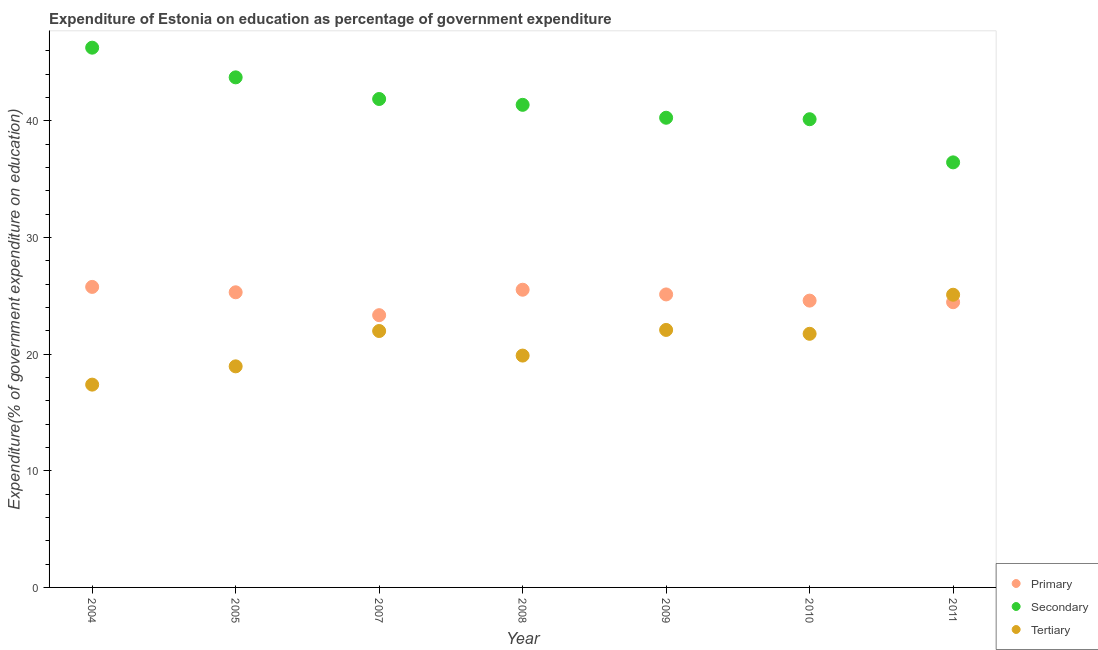Is the number of dotlines equal to the number of legend labels?
Your answer should be compact. Yes. What is the expenditure on secondary education in 2008?
Your answer should be very brief. 41.36. Across all years, what is the maximum expenditure on tertiary education?
Your response must be concise. 25.09. Across all years, what is the minimum expenditure on primary education?
Your response must be concise. 23.33. What is the total expenditure on secondary education in the graph?
Offer a very short reply. 290.02. What is the difference between the expenditure on secondary education in 2008 and that in 2011?
Offer a terse response. 4.93. What is the difference between the expenditure on tertiary education in 2011 and the expenditure on primary education in 2007?
Provide a succinct answer. 1.75. What is the average expenditure on secondary education per year?
Provide a succinct answer. 41.43. In the year 2005, what is the difference between the expenditure on secondary education and expenditure on tertiary education?
Your response must be concise. 24.77. What is the ratio of the expenditure on secondary education in 2005 to that in 2008?
Keep it short and to the point. 1.06. What is the difference between the highest and the second highest expenditure on secondary education?
Provide a succinct answer. 2.54. What is the difference between the highest and the lowest expenditure on tertiary education?
Your answer should be very brief. 7.7. In how many years, is the expenditure on primary education greater than the average expenditure on primary education taken over all years?
Make the answer very short. 4. Is it the case that in every year, the sum of the expenditure on primary education and expenditure on secondary education is greater than the expenditure on tertiary education?
Provide a short and direct response. Yes. Does the expenditure on secondary education monotonically increase over the years?
Offer a very short reply. No. Is the expenditure on tertiary education strictly greater than the expenditure on secondary education over the years?
Make the answer very short. No. How many years are there in the graph?
Offer a terse response. 7. What is the difference between two consecutive major ticks on the Y-axis?
Your answer should be compact. 10. How many legend labels are there?
Your answer should be very brief. 3. What is the title of the graph?
Your answer should be compact. Expenditure of Estonia on education as percentage of government expenditure. Does "Grants" appear as one of the legend labels in the graph?
Give a very brief answer. No. What is the label or title of the X-axis?
Make the answer very short. Year. What is the label or title of the Y-axis?
Provide a short and direct response. Expenditure(% of government expenditure on education). What is the Expenditure(% of government expenditure on education) in Primary in 2004?
Ensure brevity in your answer.  25.76. What is the Expenditure(% of government expenditure on education) in Secondary in 2004?
Keep it short and to the point. 46.26. What is the Expenditure(% of government expenditure on education) in Tertiary in 2004?
Provide a succinct answer. 17.38. What is the Expenditure(% of government expenditure on education) of Primary in 2005?
Offer a very short reply. 25.3. What is the Expenditure(% of government expenditure on education) of Secondary in 2005?
Offer a very short reply. 43.72. What is the Expenditure(% of government expenditure on education) of Tertiary in 2005?
Your answer should be very brief. 18.95. What is the Expenditure(% of government expenditure on education) of Primary in 2007?
Provide a short and direct response. 23.33. What is the Expenditure(% of government expenditure on education) of Secondary in 2007?
Provide a short and direct response. 41.86. What is the Expenditure(% of government expenditure on education) of Tertiary in 2007?
Ensure brevity in your answer.  21.98. What is the Expenditure(% of government expenditure on education) in Primary in 2008?
Make the answer very short. 25.52. What is the Expenditure(% of government expenditure on education) in Secondary in 2008?
Your answer should be compact. 41.36. What is the Expenditure(% of government expenditure on education) of Tertiary in 2008?
Provide a succinct answer. 19.87. What is the Expenditure(% of government expenditure on education) in Primary in 2009?
Give a very brief answer. 25.11. What is the Expenditure(% of government expenditure on education) in Secondary in 2009?
Offer a very short reply. 40.25. What is the Expenditure(% of government expenditure on education) in Tertiary in 2009?
Give a very brief answer. 22.07. What is the Expenditure(% of government expenditure on education) in Primary in 2010?
Make the answer very short. 24.58. What is the Expenditure(% of government expenditure on education) of Secondary in 2010?
Offer a terse response. 40.13. What is the Expenditure(% of government expenditure on education) in Tertiary in 2010?
Provide a succinct answer. 21.74. What is the Expenditure(% of government expenditure on education) in Primary in 2011?
Your answer should be very brief. 24.45. What is the Expenditure(% of government expenditure on education) of Secondary in 2011?
Keep it short and to the point. 36.43. What is the Expenditure(% of government expenditure on education) in Tertiary in 2011?
Ensure brevity in your answer.  25.09. Across all years, what is the maximum Expenditure(% of government expenditure on education) of Primary?
Make the answer very short. 25.76. Across all years, what is the maximum Expenditure(% of government expenditure on education) in Secondary?
Your answer should be compact. 46.26. Across all years, what is the maximum Expenditure(% of government expenditure on education) in Tertiary?
Ensure brevity in your answer.  25.09. Across all years, what is the minimum Expenditure(% of government expenditure on education) in Primary?
Provide a succinct answer. 23.33. Across all years, what is the minimum Expenditure(% of government expenditure on education) in Secondary?
Keep it short and to the point. 36.43. Across all years, what is the minimum Expenditure(% of government expenditure on education) in Tertiary?
Provide a succinct answer. 17.38. What is the total Expenditure(% of government expenditure on education) in Primary in the graph?
Give a very brief answer. 174.04. What is the total Expenditure(% of government expenditure on education) in Secondary in the graph?
Give a very brief answer. 290.02. What is the total Expenditure(% of government expenditure on education) in Tertiary in the graph?
Keep it short and to the point. 147.07. What is the difference between the Expenditure(% of government expenditure on education) in Primary in 2004 and that in 2005?
Offer a terse response. 0.46. What is the difference between the Expenditure(% of government expenditure on education) in Secondary in 2004 and that in 2005?
Provide a short and direct response. 2.54. What is the difference between the Expenditure(% of government expenditure on education) in Tertiary in 2004 and that in 2005?
Make the answer very short. -1.57. What is the difference between the Expenditure(% of government expenditure on education) of Primary in 2004 and that in 2007?
Offer a terse response. 2.42. What is the difference between the Expenditure(% of government expenditure on education) in Secondary in 2004 and that in 2007?
Provide a short and direct response. 4.4. What is the difference between the Expenditure(% of government expenditure on education) of Tertiary in 2004 and that in 2007?
Offer a very short reply. -4.6. What is the difference between the Expenditure(% of government expenditure on education) of Primary in 2004 and that in 2008?
Keep it short and to the point. 0.24. What is the difference between the Expenditure(% of government expenditure on education) in Secondary in 2004 and that in 2008?
Your answer should be compact. 4.9. What is the difference between the Expenditure(% of government expenditure on education) of Tertiary in 2004 and that in 2008?
Make the answer very short. -2.49. What is the difference between the Expenditure(% of government expenditure on education) in Primary in 2004 and that in 2009?
Ensure brevity in your answer.  0.65. What is the difference between the Expenditure(% of government expenditure on education) in Secondary in 2004 and that in 2009?
Offer a very short reply. 6.01. What is the difference between the Expenditure(% of government expenditure on education) of Tertiary in 2004 and that in 2009?
Your answer should be compact. -4.69. What is the difference between the Expenditure(% of government expenditure on education) in Primary in 2004 and that in 2010?
Ensure brevity in your answer.  1.18. What is the difference between the Expenditure(% of government expenditure on education) in Secondary in 2004 and that in 2010?
Your response must be concise. 6.13. What is the difference between the Expenditure(% of government expenditure on education) in Tertiary in 2004 and that in 2010?
Ensure brevity in your answer.  -4.36. What is the difference between the Expenditure(% of government expenditure on education) in Primary in 2004 and that in 2011?
Keep it short and to the point. 1.31. What is the difference between the Expenditure(% of government expenditure on education) of Secondary in 2004 and that in 2011?
Your answer should be compact. 9.83. What is the difference between the Expenditure(% of government expenditure on education) in Tertiary in 2004 and that in 2011?
Ensure brevity in your answer.  -7.7. What is the difference between the Expenditure(% of government expenditure on education) in Primary in 2005 and that in 2007?
Provide a succinct answer. 1.96. What is the difference between the Expenditure(% of government expenditure on education) of Secondary in 2005 and that in 2007?
Make the answer very short. 1.85. What is the difference between the Expenditure(% of government expenditure on education) in Tertiary in 2005 and that in 2007?
Provide a short and direct response. -3.03. What is the difference between the Expenditure(% of government expenditure on education) in Primary in 2005 and that in 2008?
Make the answer very short. -0.22. What is the difference between the Expenditure(% of government expenditure on education) in Secondary in 2005 and that in 2008?
Provide a short and direct response. 2.36. What is the difference between the Expenditure(% of government expenditure on education) of Tertiary in 2005 and that in 2008?
Ensure brevity in your answer.  -0.92. What is the difference between the Expenditure(% of government expenditure on education) of Primary in 2005 and that in 2009?
Offer a very short reply. 0.18. What is the difference between the Expenditure(% of government expenditure on education) of Secondary in 2005 and that in 2009?
Provide a succinct answer. 3.46. What is the difference between the Expenditure(% of government expenditure on education) in Tertiary in 2005 and that in 2009?
Make the answer very short. -3.12. What is the difference between the Expenditure(% of government expenditure on education) of Primary in 2005 and that in 2010?
Your answer should be compact. 0.71. What is the difference between the Expenditure(% of government expenditure on education) of Secondary in 2005 and that in 2010?
Ensure brevity in your answer.  3.59. What is the difference between the Expenditure(% of government expenditure on education) of Tertiary in 2005 and that in 2010?
Your answer should be compact. -2.79. What is the difference between the Expenditure(% of government expenditure on education) in Primary in 2005 and that in 2011?
Give a very brief answer. 0.85. What is the difference between the Expenditure(% of government expenditure on education) in Secondary in 2005 and that in 2011?
Offer a terse response. 7.29. What is the difference between the Expenditure(% of government expenditure on education) in Tertiary in 2005 and that in 2011?
Make the answer very short. -6.14. What is the difference between the Expenditure(% of government expenditure on education) in Primary in 2007 and that in 2008?
Ensure brevity in your answer.  -2.18. What is the difference between the Expenditure(% of government expenditure on education) of Secondary in 2007 and that in 2008?
Offer a terse response. 0.5. What is the difference between the Expenditure(% of government expenditure on education) in Tertiary in 2007 and that in 2008?
Provide a short and direct response. 2.11. What is the difference between the Expenditure(% of government expenditure on education) in Primary in 2007 and that in 2009?
Your answer should be very brief. -1.78. What is the difference between the Expenditure(% of government expenditure on education) in Secondary in 2007 and that in 2009?
Your answer should be very brief. 1.61. What is the difference between the Expenditure(% of government expenditure on education) of Tertiary in 2007 and that in 2009?
Give a very brief answer. -0.09. What is the difference between the Expenditure(% of government expenditure on education) in Primary in 2007 and that in 2010?
Your response must be concise. -1.25. What is the difference between the Expenditure(% of government expenditure on education) of Secondary in 2007 and that in 2010?
Your answer should be compact. 1.73. What is the difference between the Expenditure(% of government expenditure on education) in Tertiary in 2007 and that in 2010?
Your answer should be very brief. 0.24. What is the difference between the Expenditure(% of government expenditure on education) of Primary in 2007 and that in 2011?
Offer a terse response. -1.11. What is the difference between the Expenditure(% of government expenditure on education) in Secondary in 2007 and that in 2011?
Give a very brief answer. 5.43. What is the difference between the Expenditure(% of government expenditure on education) in Tertiary in 2007 and that in 2011?
Provide a succinct answer. -3.11. What is the difference between the Expenditure(% of government expenditure on education) of Primary in 2008 and that in 2009?
Your answer should be compact. 0.4. What is the difference between the Expenditure(% of government expenditure on education) in Secondary in 2008 and that in 2009?
Offer a terse response. 1.11. What is the difference between the Expenditure(% of government expenditure on education) of Tertiary in 2008 and that in 2009?
Your answer should be compact. -2.2. What is the difference between the Expenditure(% of government expenditure on education) of Primary in 2008 and that in 2010?
Make the answer very short. 0.93. What is the difference between the Expenditure(% of government expenditure on education) of Secondary in 2008 and that in 2010?
Offer a terse response. 1.23. What is the difference between the Expenditure(% of government expenditure on education) of Tertiary in 2008 and that in 2010?
Provide a short and direct response. -1.87. What is the difference between the Expenditure(% of government expenditure on education) of Primary in 2008 and that in 2011?
Your answer should be compact. 1.07. What is the difference between the Expenditure(% of government expenditure on education) of Secondary in 2008 and that in 2011?
Provide a short and direct response. 4.93. What is the difference between the Expenditure(% of government expenditure on education) of Tertiary in 2008 and that in 2011?
Make the answer very short. -5.21. What is the difference between the Expenditure(% of government expenditure on education) in Primary in 2009 and that in 2010?
Offer a terse response. 0.53. What is the difference between the Expenditure(% of government expenditure on education) in Secondary in 2009 and that in 2010?
Provide a short and direct response. 0.13. What is the difference between the Expenditure(% of government expenditure on education) in Tertiary in 2009 and that in 2010?
Make the answer very short. 0.33. What is the difference between the Expenditure(% of government expenditure on education) in Primary in 2009 and that in 2011?
Provide a short and direct response. 0.67. What is the difference between the Expenditure(% of government expenditure on education) of Secondary in 2009 and that in 2011?
Provide a short and direct response. 3.82. What is the difference between the Expenditure(% of government expenditure on education) of Tertiary in 2009 and that in 2011?
Provide a short and direct response. -3.02. What is the difference between the Expenditure(% of government expenditure on education) of Primary in 2010 and that in 2011?
Your response must be concise. 0.14. What is the difference between the Expenditure(% of government expenditure on education) of Secondary in 2010 and that in 2011?
Your answer should be very brief. 3.7. What is the difference between the Expenditure(% of government expenditure on education) in Tertiary in 2010 and that in 2011?
Give a very brief answer. -3.35. What is the difference between the Expenditure(% of government expenditure on education) in Primary in 2004 and the Expenditure(% of government expenditure on education) in Secondary in 2005?
Offer a very short reply. -17.96. What is the difference between the Expenditure(% of government expenditure on education) in Primary in 2004 and the Expenditure(% of government expenditure on education) in Tertiary in 2005?
Keep it short and to the point. 6.81. What is the difference between the Expenditure(% of government expenditure on education) of Secondary in 2004 and the Expenditure(% of government expenditure on education) of Tertiary in 2005?
Provide a short and direct response. 27.31. What is the difference between the Expenditure(% of government expenditure on education) of Primary in 2004 and the Expenditure(% of government expenditure on education) of Secondary in 2007?
Provide a succinct answer. -16.1. What is the difference between the Expenditure(% of government expenditure on education) in Primary in 2004 and the Expenditure(% of government expenditure on education) in Tertiary in 2007?
Your response must be concise. 3.78. What is the difference between the Expenditure(% of government expenditure on education) in Secondary in 2004 and the Expenditure(% of government expenditure on education) in Tertiary in 2007?
Offer a terse response. 24.28. What is the difference between the Expenditure(% of government expenditure on education) of Primary in 2004 and the Expenditure(% of government expenditure on education) of Secondary in 2008?
Offer a terse response. -15.6. What is the difference between the Expenditure(% of government expenditure on education) in Primary in 2004 and the Expenditure(% of government expenditure on education) in Tertiary in 2008?
Keep it short and to the point. 5.89. What is the difference between the Expenditure(% of government expenditure on education) in Secondary in 2004 and the Expenditure(% of government expenditure on education) in Tertiary in 2008?
Your answer should be compact. 26.39. What is the difference between the Expenditure(% of government expenditure on education) in Primary in 2004 and the Expenditure(% of government expenditure on education) in Secondary in 2009?
Your answer should be compact. -14.5. What is the difference between the Expenditure(% of government expenditure on education) of Primary in 2004 and the Expenditure(% of government expenditure on education) of Tertiary in 2009?
Offer a very short reply. 3.69. What is the difference between the Expenditure(% of government expenditure on education) in Secondary in 2004 and the Expenditure(% of government expenditure on education) in Tertiary in 2009?
Offer a terse response. 24.19. What is the difference between the Expenditure(% of government expenditure on education) in Primary in 2004 and the Expenditure(% of government expenditure on education) in Secondary in 2010?
Your answer should be very brief. -14.37. What is the difference between the Expenditure(% of government expenditure on education) of Primary in 2004 and the Expenditure(% of government expenditure on education) of Tertiary in 2010?
Give a very brief answer. 4.02. What is the difference between the Expenditure(% of government expenditure on education) in Secondary in 2004 and the Expenditure(% of government expenditure on education) in Tertiary in 2010?
Give a very brief answer. 24.52. What is the difference between the Expenditure(% of government expenditure on education) of Primary in 2004 and the Expenditure(% of government expenditure on education) of Secondary in 2011?
Offer a very short reply. -10.67. What is the difference between the Expenditure(% of government expenditure on education) in Primary in 2004 and the Expenditure(% of government expenditure on education) in Tertiary in 2011?
Your response must be concise. 0.67. What is the difference between the Expenditure(% of government expenditure on education) in Secondary in 2004 and the Expenditure(% of government expenditure on education) in Tertiary in 2011?
Ensure brevity in your answer.  21.18. What is the difference between the Expenditure(% of government expenditure on education) in Primary in 2005 and the Expenditure(% of government expenditure on education) in Secondary in 2007?
Provide a short and direct response. -16.57. What is the difference between the Expenditure(% of government expenditure on education) in Primary in 2005 and the Expenditure(% of government expenditure on education) in Tertiary in 2007?
Offer a terse response. 3.32. What is the difference between the Expenditure(% of government expenditure on education) in Secondary in 2005 and the Expenditure(% of government expenditure on education) in Tertiary in 2007?
Offer a terse response. 21.74. What is the difference between the Expenditure(% of government expenditure on education) of Primary in 2005 and the Expenditure(% of government expenditure on education) of Secondary in 2008?
Make the answer very short. -16.07. What is the difference between the Expenditure(% of government expenditure on education) of Primary in 2005 and the Expenditure(% of government expenditure on education) of Tertiary in 2008?
Provide a succinct answer. 5.42. What is the difference between the Expenditure(% of government expenditure on education) of Secondary in 2005 and the Expenditure(% of government expenditure on education) of Tertiary in 2008?
Your response must be concise. 23.85. What is the difference between the Expenditure(% of government expenditure on education) in Primary in 2005 and the Expenditure(% of government expenditure on education) in Secondary in 2009?
Provide a succinct answer. -14.96. What is the difference between the Expenditure(% of government expenditure on education) of Primary in 2005 and the Expenditure(% of government expenditure on education) of Tertiary in 2009?
Your answer should be compact. 3.23. What is the difference between the Expenditure(% of government expenditure on education) of Secondary in 2005 and the Expenditure(% of government expenditure on education) of Tertiary in 2009?
Provide a succinct answer. 21.65. What is the difference between the Expenditure(% of government expenditure on education) of Primary in 2005 and the Expenditure(% of government expenditure on education) of Secondary in 2010?
Keep it short and to the point. -14.83. What is the difference between the Expenditure(% of government expenditure on education) in Primary in 2005 and the Expenditure(% of government expenditure on education) in Tertiary in 2010?
Provide a short and direct response. 3.56. What is the difference between the Expenditure(% of government expenditure on education) of Secondary in 2005 and the Expenditure(% of government expenditure on education) of Tertiary in 2010?
Keep it short and to the point. 21.98. What is the difference between the Expenditure(% of government expenditure on education) of Primary in 2005 and the Expenditure(% of government expenditure on education) of Secondary in 2011?
Your answer should be compact. -11.13. What is the difference between the Expenditure(% of government expenditure on education) of Primary in 2005 and the Expenditure(% of government expenditure on education) of Tertiary in 2011?
Your answer should be very brief. 0.21. What is the difference between the Expenditure(% of government expenditure on education) in Secondary in 2005 and the Expenditure(% of government expenditure on education) in Tertiary in 2011?
Give a very brief answer. 18.63. What is the difference between the Expenditure(% of government expenditure on education) in Primary in 2007 and the Expenditure(% of government expenditure on education) in Secondary in 2008?
Your response must be concise. -18.03. What is the difference between the Expenditure(% of government expenditure on education) of Primary in 2007 and the Expenditure(% of government expenditure on education) of Tertiary in 2008?
Give a very brief answer. 3.46. What is the difference between the Expenditure(% of government expenditure on education) in Secondary in 2007 and the Expenditure(% of government expenditure on education) in Tertiary in 2008?
Offer a terse response. 21.99. What is the difference between the Expenditure(% of government expenditure on education) in Primary in 2007 and the Expenditure(% of government expenditure on education) in Secondary in 2009?
Keep it short and to the point. -16.92. What is the difference between the Expenditure(% of government expenditure on education) in Primary in 2007 and the Expenditure(% of government expenditure on education) in Tertiary in 2009?
Give a very brief answer. 1.26. What is the difference between the Expenditure(% of government expenditure on education) of Secondary in 2007 and the Expenditure(% of government expenditure on education) of Tertiary in 2009?
Offer a very short reply. 19.79. What is the difference between the Expenditure(% of government expenditure on education) of Primary in 2007 and the Expenditure(% of government expenditure on education) of Secondary in 2010?
Offer a very short reply. -16.79. What is the difference between the Expenditure(% of government expenditure on education) in Primary in 2007 and the Expenditure(% of government expenditure on education) in Tertiary in 2010?
Ensure brevity in your answer.  1.6. What is the difference between the Expenditure(% of government expenditure on education) in Secondary in 2007 and the Expenditure(% of government expenditure on education) in Tertiary in 2010?
Your answer should be very brief. 20.12. What is the difference between the Expenditure(% of government expenditure on education) of Primary in 2007 and the Expenditure(% of government expenditure on education) of Secondary in 2011?
Give a very brief answer. -13.1. What is the difference between the Expenditure(% of government expenditure on education) in Primary in 2007 and the Expenditure(% of government expenditure on education) in Tertiary in 2011?
Provide a succinct answer. -1.75. What is the difference between the Expenditure(% of government expenditure on education) of Secondary in 2007 and the Expenditure(% of government expenditure on education) of Tertiary in 2011?
Provide a short and direct response. 16.78. What is the difference between the Expenditure(% of government expenditure on education) in Primary in 2008 and the Expenditure(% of government expenditure on education) in Secondary in 2009?
Provide a short and direct response. -14.74. What is the difference between the Expenditure(% of government expenditure on education) of Primary in 2008 and the Expenditure(% of government expenditure on education) of Tertiary in 2009?
Give a very brief answer. 3.45. What is the difference between the Expenditure(% of government expenditure on education) of Secondary in 2008 and the Expenditure(% of government expenditure on education) of Tertiary in 2009?
Keep it short and to the point. 19.29. What is the difference between the Expenditure(% of government expenditure on education) of Primary in 2008 and the Expenditure(% of government expenditure on education) of Secondary in 2010?
Your answer should be compact. -14.61. What is the difference between the Expenditure(% of government expenditure on education) in Primary in 2008 and the Expenditure(% of government expenditure on education) in Tertiary in 2010?
Give a very brief answer. 3.78. What is the difference between the Expenditure(% of government expenditure on education) in Secondary in 2008 and the Expenditure(% of government expenditure on education) in Tertiary in 2010?
Provide a succinct answer. 19.62. What is the difference between the Expenditure(% of government expenditure on education) of Primary in 2008 and the Expenditure(% of government expenditure on education) of Secondary in 2011?
Offer a very short reply. -10.91. What is the difference between the Expenditure(% of government expenditure on education) of Primary in 2008 and the Expenditure(% of government expenditure on education) of Tertiary in 2011?
Keep it short and to the point. 0.43. What is the difference between the Expenditure(% of government expenditure on education) in Secondary in 2008 and the Expenditure(% of government expenditure on education) in Tertiary in 2011?
Offer a terse response. 16.28. What is the difference between the Expenditure(% of government expenditure on education) in Primary in 2009 and the Expenditure(% of government expenditure on education) in Secondary in 2010?
Your answer should be very brief. -15.02. What is the difference between the Expenditure(% of government expenditure on education) in Primary in 2009 and the Expenditure(% of government expenditure on education) in Tertiary in 2010?
Your response must be concise. 3.37. What is the difference between the Expenditure(% of government expenditure on education) in Secondary in 2009 and the Expenditure(% of government expenditure on education) in Tertiary in 2010?
Provide a short and direct response. 18.52. What is the difference between the Expenditure(% of government expenditure on education) of Primary in 2009 and the Expenditure(% of government expenditure on education) of Secondary in 2011?
Your answer should be very brief. -11.32. What is the difference between the Expenditure(% of government expenditure on education) of Primary in 2009 and the Expenditure(% of government expenditure on education) of Tertiary in 2011?
Your answer should be compact. 0.03. What is the difference between the Expenditure(% of government expenditure on education) in Secondary in 2009 and the Expenditure(% of government expenditure on education) in Tertiary in 2011?
Offer a terse response. 15.17. What is the difference between the Expenditure(% of government expenditure on education) in Primary in 2010 and the Expenditure(% of government expenditure on education) in Secondary in 2011?
Your response must be concise. -11.85. What is the difference between the Expenditure(% of government expenditure on education) of Primary in 2010 and the Expenditure(% of government expenditure on education) of Tertiary in 2011?
Your answer should be compact. -0.5. What is the difference between the Expenditure(% of government expenditure on education) in Secondary in 2010 and the Expenditure(% of government expenditure on education) in Tertiary in 2011?
Your answer should be compact. 15.04. What is the average Expenditure(% of government expenditure on education) of Primary per year?
Provide a succinct answer. 24.86. What is the average Expenditure(% of government expenditure on education) of Secondary per year?
Your answer should be compact. 41.43. What is the average Expenditure(% of government expenditure on education) in Tertiary per year?
Your response must be concise. 21.01. In the year 2004, what is the difference between the Expenditure(% of government expenditure on education) in Primary and Expenditure(% of government expenditure on education) in Secondary?
Offer a very short reply. -20.5. In the year 2004, what is the difference between the Expenditure(% of government expenditure on education) of Primary and Expenditure(% of government expenditure on education) of Tertiary?
Make the answer very short. 8.38. In the year 2004, what is the difference between the Expenditure(% of government expenditure on education) in Secondary and Expenditure(% of government expenditure on education) in Tertiary?
Provide a succinct answer. 28.88. In the year 2005, what is the difference between the Expenditure(% of government expenditure on education) of Primary and Expenditure(% of government expenditure on education) of Secondary?
Provide a short and direct response. -18.42. In the year 2005, what is the difference between the Expenditure(% of government expenditure on education) in Primary and Expenditure(% of government expenditure on education) in Tertiary?
Your answer should be very brief. 6.35. In the year 2005, what is the difference between the Expenditure(% of government expenditure on education) of Secondary and Expenditure(% of government expenditure on education) of Tertiary?
Your answer should be very brief. 24.77. In the year 2007, what is the difference between the Expenditure(% of government expenditure on education) of Primary and Expenditure(% of government expenditure on education) of Secondary?
Offer a very short reply. -18.53. In the year 2007, what is the difference between the Expenditure(% of government expenditure on education) in Primary and Expenditure(% of government expenditure on education) in Tertiary?
Offer a terse response. 1.36. In the year 2007, what is the difference between the Expenditure(% of government expenditure on education) of Secondary and Expenditure(% of government expenditure on education) of Tertiary?
Ensure brevity in your answer.  19.89. In the year 2008, what is the difference between the Expenditure(% of government expenditure on education) in Primary and Expenditure(% of government expenditure on education) in Secondary?
Give a very brief answer. -15.85. In the year 2008, what is the difference between the Expenditure(% of government expenditure on education) of Primary and Expenditure(% of government expenditure on education) of Tertiary?
Your answer should be compact. 5.64. In the year 2008, what is the difference between the Expenditure(% of government expenditure on education) of Secondary and Expenditure(% of government expenditure on education) of Tertiary?
Provide a succinct answer. 21.49. In the year 2009, what is the difference between the Expenditure(% of government expenditure on education) in Primary and Expenditure(% of government expenditure on education) in Secondary?
Ensure brevity in your answer.  -15.14. In the year 2009, what is the difference between the Expenditure(% of government expenditure on education) of Primary and Expenditure(% of government expenditure on education) of Tertiary?
Make the answer very short. 3.04. In the year 2009, what is the difference between the Expenditure(% of government expenditure on education) in Secondary and Expenditure(% of government expenditure on education) in Tertiary?
Give a very brief answer. 18.19. In the year 2010, what is the difference between the Expenditure(% of government expenditure on education) in Primary and Expenditure(% of government expenditure on education) in Secondary?
Offer a very short reply. -15.55. In the year 2010, what is the difference between the Expenditure(% of government expenditure on education) of Primary and Expenditure(% of government expenditure on education) of Tertiary?
Your answer should be very brief. 2.84. In the year 2010, what is the difference between the Expenditure(% of government expenditure on education) of Secondary and Expenditure(% of government expenditure on education) of Tertiary?
Give a very brief answer. 18.39. In the year 2011, what is the difference between the Expenditure(% of government expenditure on education) of Primary and Expenditure(% of government expenditure on education) of Secondary?
Offer a very short reply. -11.98. In the year 2011, what is the difference between the Expenditure(% of government expenditure on education) of Primary and Expenditure(% of government expenditure on education) of Tertiary?
Offer a terse response. -0.64. In the year 2011, what is the difference between the Expenditure(% of government expenditure on education) of Secondary and Expenditure(% of government expenditure on education) of Tertiary?
Keep it short and to the point. 11.34. What is the ratio of the Expenditure(% of government expenditure on education) in Primary in 2004 to that in 2005?
Ensure brevity in your answer.  1.02. What is the ratio of the Expenditure(% of government expenditure on education) of Secondary in 2004 to that in 2005?
Keep it short and to the point. 1.06. What is the ratio of the Expenditure(% of government expenditure on education) in Tertiary in 2004 to that in 2005?
Keep it short and to the point. 0.92. What is the ratio of the Expenditure(% of government expenditure on education) in Primary in 2004 to that in 2007?
Offer a terse response. 1.1. What is the ratio of the Expenditure(% of government expenditure on education) of Secondary in 2004 to that in 2007?
Your answer should be very brief. 1.11. What is the ratio of the Expenditure(% of government expenditure on education) in Tertiary in 2004 to that in 2007?
Give a very brief answer. 0.79. What is the ratio of the Expenditure(% of government expenditure on education) in Primary in 2004 to that in 2008?
Offer a very short reply. 1.01. What is the ratio of the Expenditure(% of government expenditure on education) in Secondary in 2004 to that in 2008?
Make the answer very short. 1.12. What is the ratio of the Expenditure(% of government expenditure on education) in Tertiary in 2004 to that in 2008?
Your response must be concise. 0.87. What is the ratio of the Expenditure(% of government expenditure on education) in Primary in 2004 to that in 2009?
Keep it short and to the point. 1.03. What is the ratio of the Expenditure(% of government expenditure on education) in Secondary in 2004 to that in 2009?
Keep it short and to the point. 1.15. What is the ratio of the Expenditure(% of government expenditure on education) of Tertiary in 2004 to that in 2009?
Provide a succinct answer. 0.79. What is the ratio of the Expenditure(% of government expenditure on education) of Primary in 2004 to that in 2010?
Provide a short and direct response. 1.05. What is the ratio of the Expenditure(% of government expenditure on education) in Secondary in 2004 to that in 2010?
Provide a succinct answer. 1.15. What is the ratio of the Expenditure(% of government expenditure on education) in Tertiary in 2004 to that in 2010?
Offer a very short reply. 0.8. What is the ratio of the Expenditure(% of government expenditure on education) of Primary in 2004 to that in 2011?
Your response must be concise. 1.05. What is the ratio of the Expenditure(% of government expenditure on education) of Secondary in 2004 to that in 2011?
Give a very brief answer. 1.27. What is the ratio of the Expenditure(% of government expenditure on education) in Tertiary in 2004 to that in 2011?
Give a very brief answer. 0.69. What is the ratio of the Expenditure(% of government expenditure on education) in Primary in 2005 to that in 2007?
Provide a short and direct response. 1.08. What is the ratio of the Expenditure(% of government expenditure on education) of Secondary in 2005 to that in 2007?
Your response must be concise. 1.04. What is the ratio of the Expenditure(% of government expenditure on education) in Tertiary in 2005 to that in 2007?
Your response must be concise. 0.86. What is the ratio of the Expenditure(% of government expenditure on education) in Primary in 2005 to that in 2008?
Make the answer very short. 0.99. What is the ratio of the Expenditure(% of government expenditure on education) in Secondary in 2005 to that in 2008?
Keep it short and to the point. 1.06. What is the ratio of the Expenditure(% of government expenditure on education) of Tertiary in 2005 to that in 2008?
Provide a short and direct response. 0.95. What is the ratio of the Expenditure(% of government expenditure on education) in Primary in 2005 to that in 2009?
Offer a very short reply. 1.01. What is the ratio of the Expenditure(% of government expenditure on education) of Secondary in 2005 to that in 2009?
Offer a terse response. 1.09. What is the ratio of the Expenditure(% of government expenditure on education) of Tertiary in 2005 to that in 2009?
Offer a very short reply. 0.86. What is the ratio of the Expenditure(% of government expenditure on education) in Secondary in 2005 to that in 2010?
Ensure brevity in your answer.  1.09. What is the ratio of the Expenditure(% of government expenditure on education) of Tertiary in 2005 to that in 2010?
Provide a short and direct response. 0.87. What is the ratio of the Expenditure(% of government expenditure on education) in Primary in 2005 to that in 2011?
Your answer should be very brief. 1.03. What is the ratio of the Expenditure(% of government expenditure on education) of Tertiary in 2005 to that in 2011?
Your response must be concise. 0.76. What is the ratio of the Expenditure(% of government expenditure on education) of Primary in 2007 to that in 2008?
Provide a succinct answer. 0.91. What is the ratio of the Expenditure(% of government expenditure on education) of Secondary in 2007 to that in 2008?
Offer a very short reply. 1.01. What is the ratio of the Expenditure(% of government expenditure on education) of Tertiary in 2007 to that in 2008?
Offer a very short reply. 1.11. What is the ratio of the Expenditure(% of government expenditure on education) in Primary in 2007 to that in 2009?
Your answer should be compact. 0.93. What is the ratio of the Expenditure(% of government expenditure on education) in Secondary in 2007 to that in 2009?
Give a very brief answer. 1.04. What is the ratio of the Expenditure(% of government expenditure on education) in Tertiary in 2007 to that in 2009?
Ensure brevity in your answer.  1. What is the ratio of the Expenditure(% of government expenditure on education) of Primary in 2007 to that in 2010?
Give a very brief answer. 0.95. What is the ratio of the Expenditure(% of government expenditure on education) in Secondary in 2007 to that in 2010?
Provide a short and direct response. 1.04. What is the ratio of the Expenditure(% of government expenditure on education) in Primary in 2007 to that in 2011?
Keep it short and to the point. 0.95. What is the ratio of the Expenditure(% of government expenditure on education) in Secondary in 2007 to that in 2011?
Provide a short and direct response. 1.15. What is the ratio of the Expenditure(% of government expenditure on education) of Tertiary in 2007 to that in 2011?
Offer a very short reply. 0.88. What is the ratio of the Expenditure(% of government expenditure on education) of Primary in 2008 to that in 2009?
Ensure brevity in your answer.  1.02. What is the ratio of the Expenditure(% of government expenditure on education) of Secondary in 2008 to that in 2009?
Provide a short and direct response. 1.03. What is the ratio of the Expenditure(% of government expenditure on education) of Tertiary in 2008 to that in 2009?
Your response must be concise. 0.9. What is the ratio of the Expenditure(% of government expenditure on education) of Primary in 2008 to that in 2010?
Offer a very short reply. 1.04. What is the ratio of the Expenditure(% of government expenditure on education) of Secondary in 2008 to that in 2010?
Provide a succinct answer. 1.03. What is the ratio of the Expenditure(% of government expenditure on education) of Tertiary in 2008 to that in 2010?
Your answer should be very brief. 0.91. What is the ratio of the Expenditure(% of government expenditure on education) of Primary in 2008 to that in 2011?
Ensure brevity in your answer.  1.04. What is the ratio of the Expenditure(% of government expenditure on education) in Secondary in 2008 to that in 2011?
Provide a short and direct response. 1.14. What is the ratio of the Expenditure(% of government expenditure on education) in Tertiary in 2008 to that in 2011?
Make the answer very short. 0.79. What is the ratio of the Expenditure(% of government expenditure on education) in Primary in 2009 to that in 2010?
Your answer should be very brief. 1.02. What is the ratio of the Expenditure(% of government expenditure on education) in Tertiary in 2009 to that in 2010?
Offer a very short reply. 1.02. What is the ratio of the Expenditure(% of government expenditure on education) in Primary in 2009 to that in 2011?
Ensure brevity in your answer.  1.03. What is the ratio of the Expenditure(% of government expenditure on education) of Secondary in 2009 to that in 2011?
Offer a very short reply. 1.1. What is the ratio of the Expenditure(% of government expenditure on education) of Tertiary in 2009 to that in 2011?
Your response must be concise. 0.88. What is the ratio of the Expenditure(% of government expenditure on education) in Primary in 2010 to that in 2011?
Make the answer very short. 1.01. What is the ratio of the Expenditure(% of government expenditure on education) in Secondary in 2010 to that in 2011?
Your answer should be compact. 1.1. What is the ratio of the Expenditure(% of government expenditure on education) in Tertiary in 2010 to that in 2011?
Ensure brevity in your answer.  0.87. What is the difference between the highest and the second highest Expenditure(% of government expenditure on education) in Primary?
Offer a very short reply. 0.24. What is the difference between the highest and the second highest Expenditure(% of government expenditure on education) in Secondary?
Provide a succinct answer. 2.54. What is the difference between the highest and the second highest Expenditure(% of government expenditure on education) in Tertiary?
Make the answer very short. 3.02. What is the difference between the highest and the lowest Expenditure(% of government expenditure on education) in Primary?
Make the answer very short. 2.42. What is the difference between the highest and the lowest Expenditure(% of government expenditure on education) in Secondary?
Your answer should be compact. 9.83. What is the difference between the highest and the lowest Expenditure(% of government expenditure on education) of Tertiary?
Your answer should be compact. 7.7. 